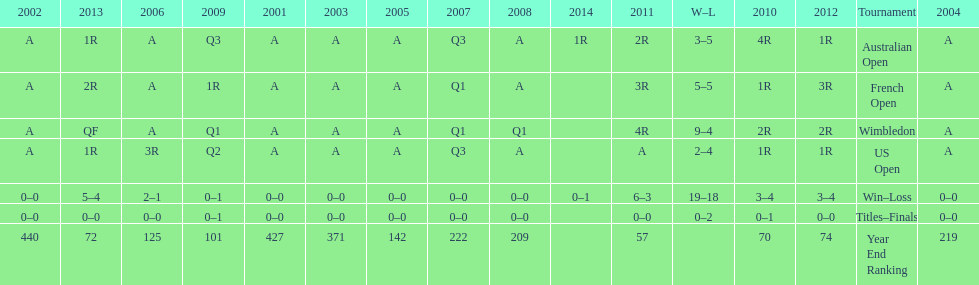What is the discrepancy in victories between wimbledon and the us open for this athlete? 7. 